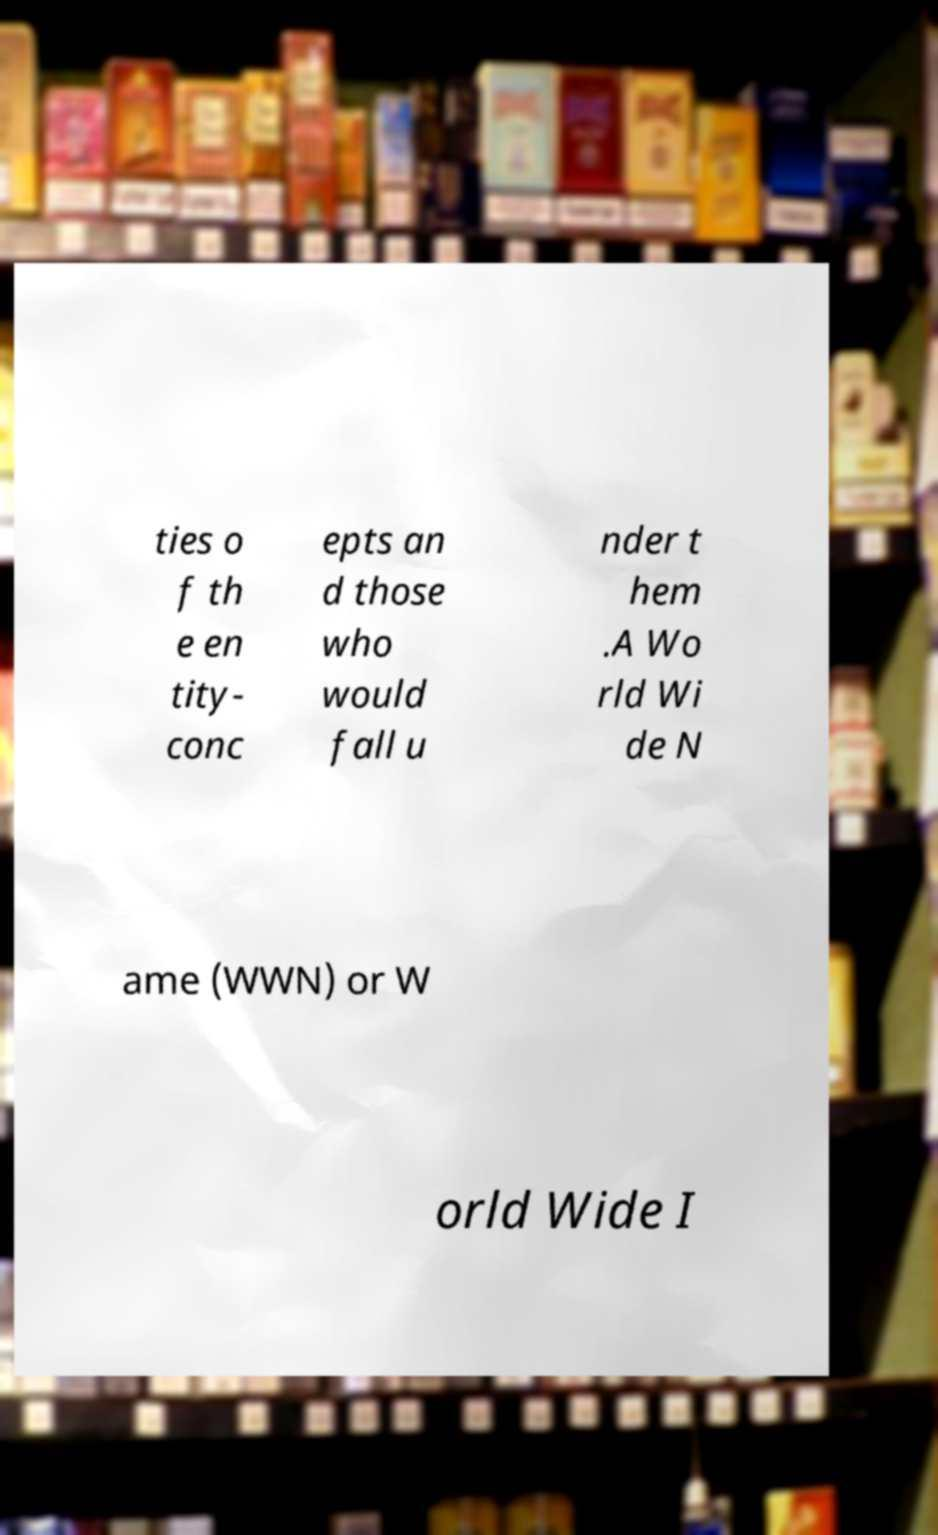Could you extract and type out the text from this image? ties o f th e en tity- conc epts an d those who would fall u nder t hem .A Wo rld Wi de N ame (WWN) or W orld Wide I 